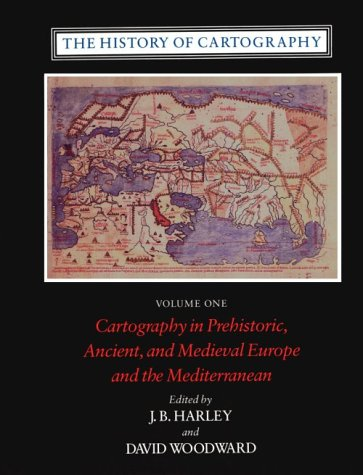Is this book related to Science & Math? Yes, this book is deeply connected to Science & Math, as it explores the disciplined practices and calculations involved in map-making throughout history. 